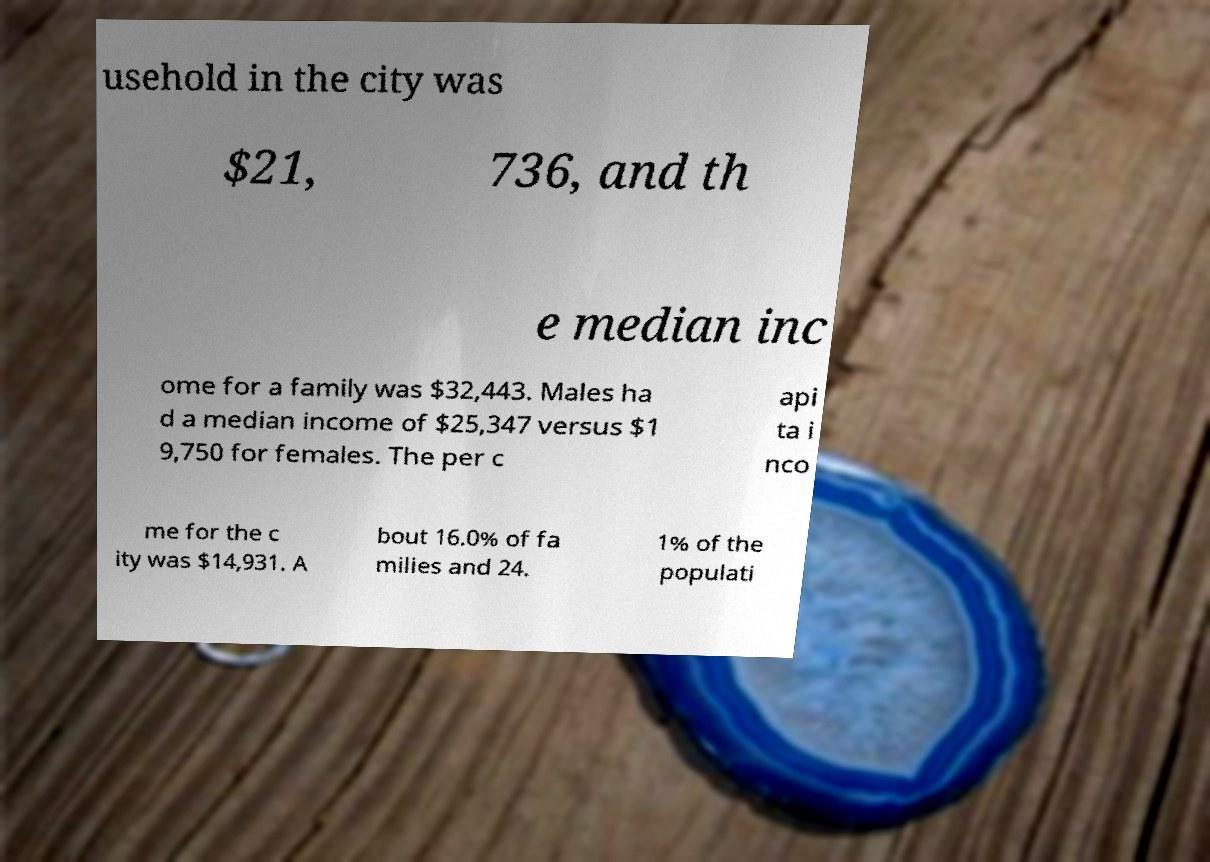I need the written content from this picture converted into text. Can you do that? usehold in the city was $21, 736, and th e median inc ome for a family was $32,443. Males ha d a median income of $25,347 versus $1 9,750 for females. The per c api ta i nco me for the c ity was $14,931. A bout 16.0% of fa milies and 24. 1% of the populati 